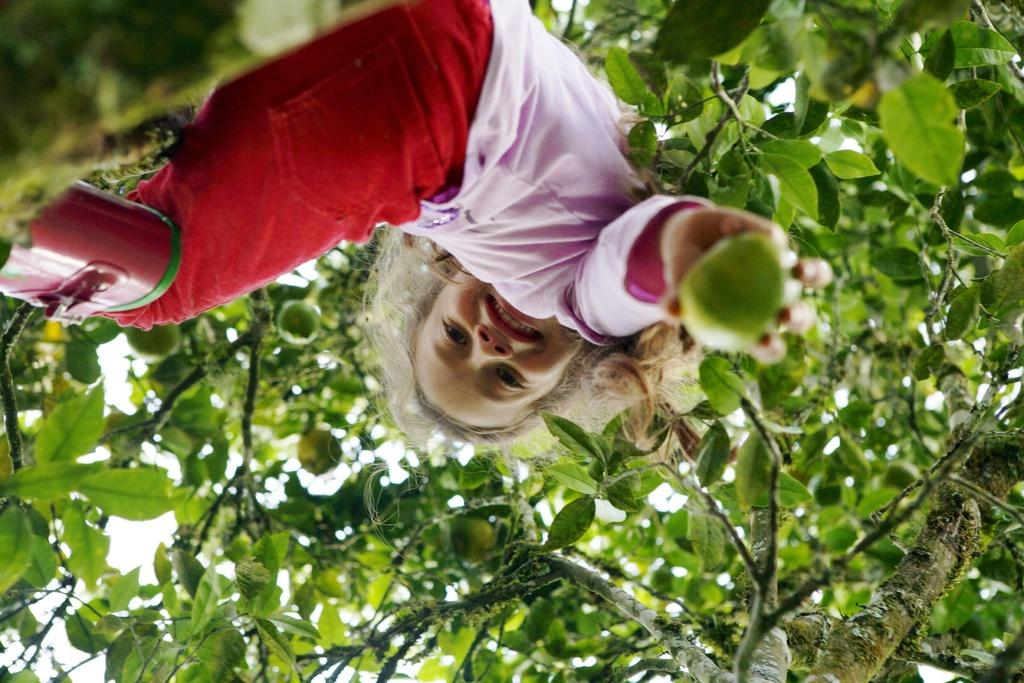Who is the main subject in the image? There is a girl in the image. What is the girl doing in the image? The girl is standing in the image. What is the girl holding in her hands? The girl is holding a fruit in her hands. What can be seen in the background of the image? There is a tree and the sky visible in the image. What type of cord is hanging from the tree in the image? There is no cord hanging from the tree in the image; only the girl, the fruit, the tree, and the sky are present. 